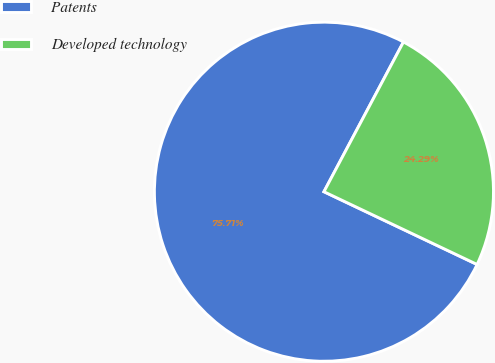<chart> <loc_0><loc_0><loc_500><loc_500><pie_chart><fcel>Patents<fcel>Developed technology<nl><fcel>75.71%<fcel>24.29%<nl></chart> 